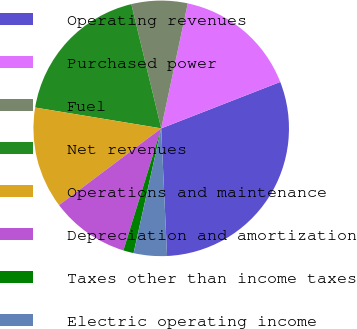Convert chart to OTSL. <chart><loc_0><loc_0><loc_500><loc_500><pie_chart><fcel>Operating revenues<fcel>Purchased power<fcel>Fuel<fcel>Net revenues<fcel>Operations and maintenance<fcel>Depreciation and amortization<fcel>Taxes other than income taxes<fcel>Electric operating income<nl><fcel>30.19%<fcel>15.75%<fcel>7.09%<fcel>18.64%<fcel>12.86%<fcel>9.97%<fcel>1.31%<fcel>4.2%<nl></chart> 